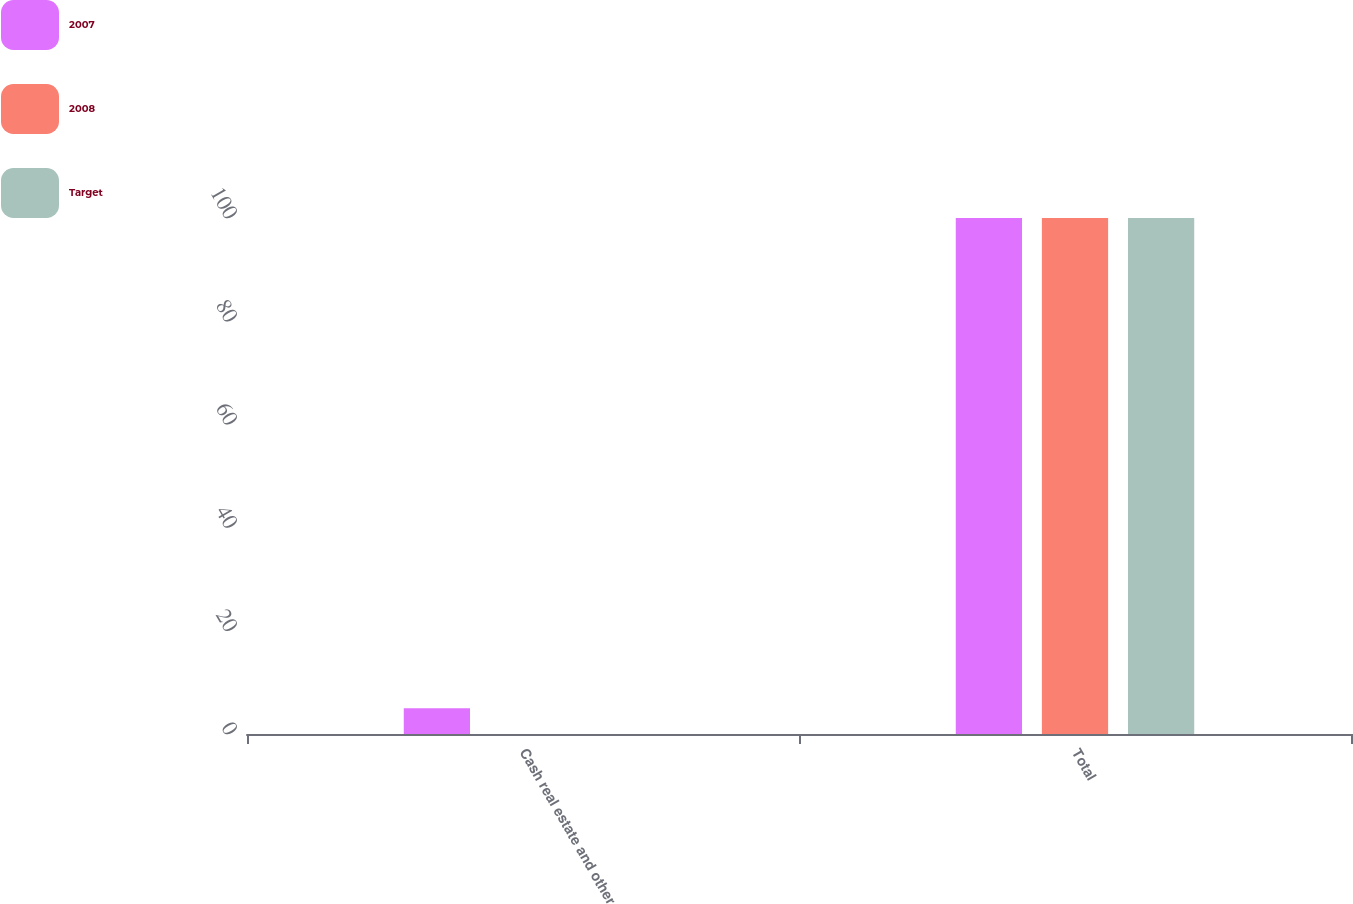<chart> <loc_0><loc_0><loc_500><loc_500><stacked_bar_chart><ecel><fcel>Cash real estate and other<fcel>Total<nl><fcel>2007<fcel>5<fcel>100<nl><fcel>2008<fcel>0<fcel>100<nl><fcel>Target<fcel>0<fcel>100<nl></chart> 